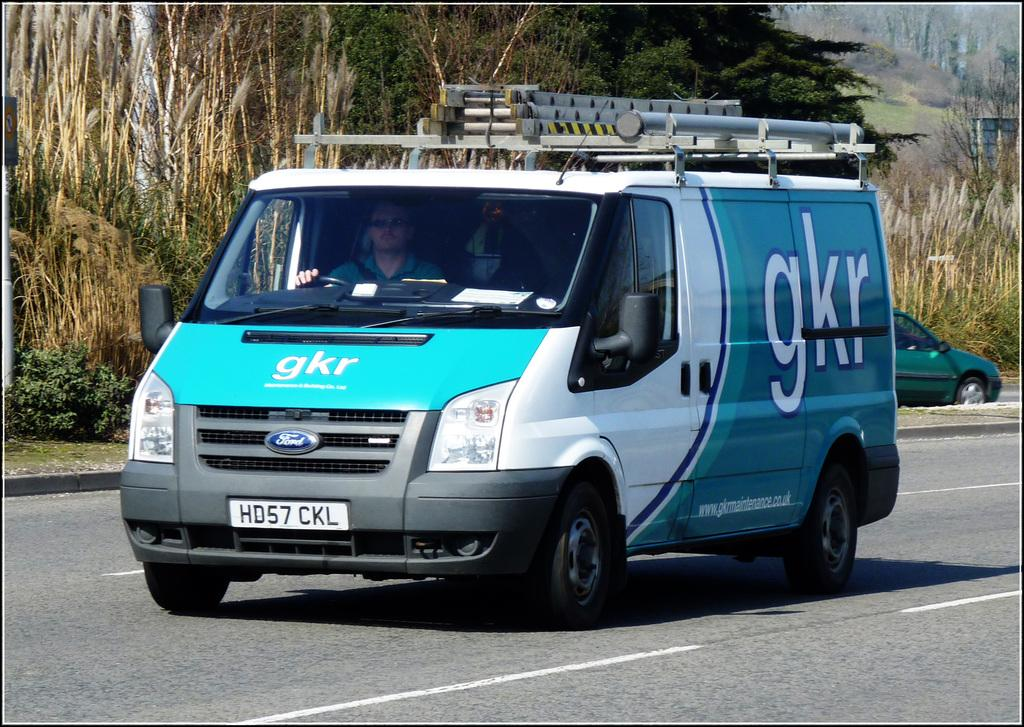<image>
Write a terse but informative summary of the picture. Van on the road with the letters GKR on the back. 